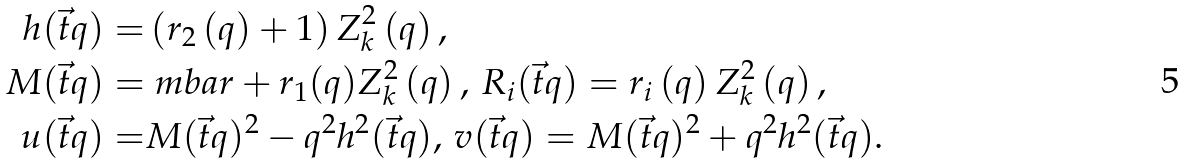<formula> <loc_0><loc_0><loc_500><loc_500>h ( \vec { t } q ) = & \left ( r _ { 2 } \left ( q \right ) + 1 \right ) Z ^ { 2 } _ { k } \left ( q \right ) , \\ M ( \vec { t } q ) = & \ m b a r + r _ { 1 } ( q ) Z ^ { 2 } _ { k } \left ( q \right ) , \, R _ { i } ( \vec { t } q ) = r _ { i } \left ( q \right ) Z _ { k } ^ { 2 } \left ( q \right ) , \\ u ( \vec { t } q ) = & M ( \vec { t } q ) ^ { 2 } - q ^ { 2 } h ^ { 2 } ( \vec { t } q ) , \, v ( \vec { t } q ) = M ( \vec { t } q ) ^ { 2 } + q ^ { 2 } h ^ { 2 } ( \vec { t } q ) .</formula> 